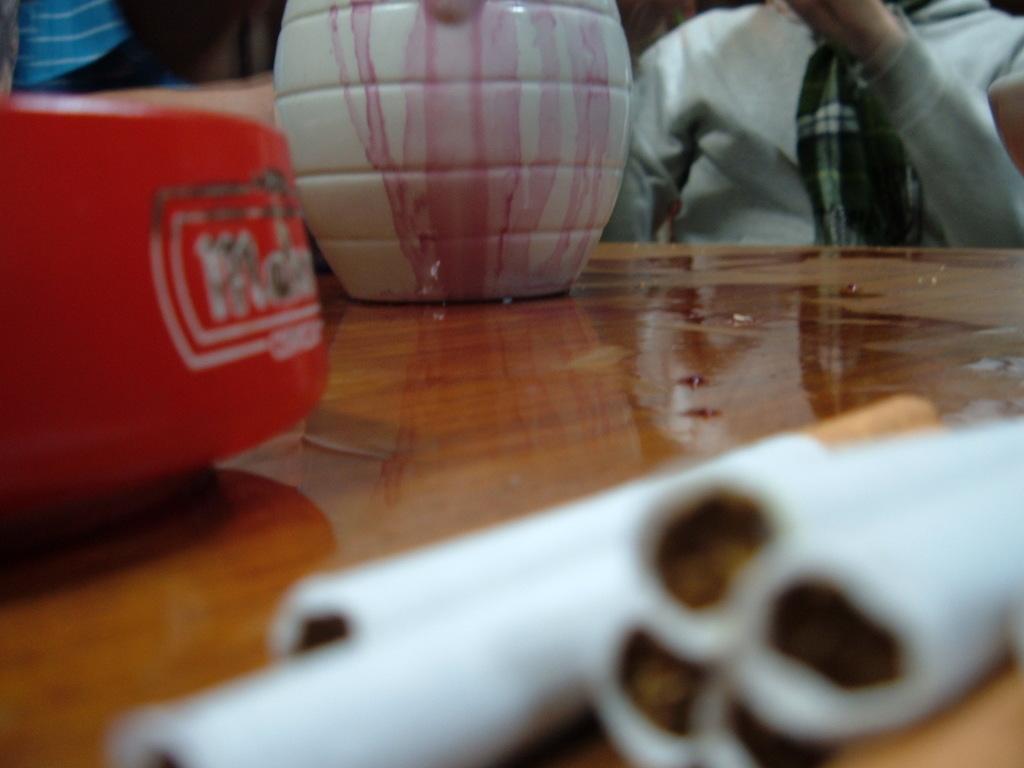In one or two sentences, can you explain what this image depicts? This is a zoomed in picture. In the foreground there is a wooden table on the top of which we can see the cigarettes and some other objects are placed. In the background there is a person wearing a scarf and seems to be sitting. 